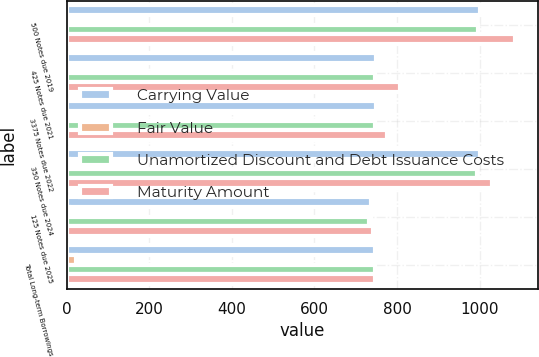Convert chart to OTSL. <chart><loc_0><loc_0><loc_500><loc_500><stacked_bar_chart><ecel><fcel>500 Notes due 2019<fcel>425 Notes due 2021<fcel>3375 Notes due 2022<fcel>350 Notes due 2024<fcel>125 Notes due 2025<fcel>Total Long-term Borrowings<nl><fcel>Carrying Value<fcel>1000<fcel>750<fcel>750<fcel>1000<fcel>738<fcel>746<nl><fcel>Fair Value<fcel>3<fcel>4<fcel>4<fcel>6<fcel>6<fcel>23<nl><fcel>Unamortized Discount and Debt Issuance Costs<fcel>997<fcel>746<fcel>746<fcel>994<fcel>732<fcel>746<nl><fcel>Maturity Amount<fcel>1086<fcel>808<fcel>775<fcel>1030<fcel>742<fcel>746<nl></chart> 